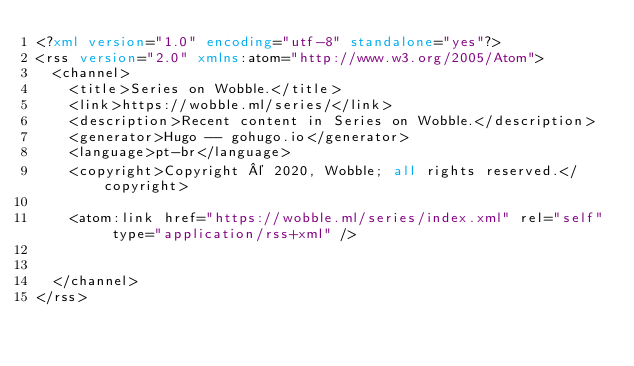Convert code to text. <code><loc_0><loc_0><loc_500><loc_500><_XML_><?xml version="1.0" encoding="utf-8" standalone="yes"?>
<rss version="2.0" xmlns:atom="http://www.w3.org/2005/Atom">
  <channel>
    <title>Series on Wobble.</title>
    <link>https://wobble.ml/series/</link>
    <description>Recent content in Series on Wobble.</description>
    <generator>Hugo -- gohugo.io</generator>
    <language>pt-br</language>
    <copyright>Copyright © 2020, Wobble; all rights reserved.</copyright>
    
	<atom:link href="https://wobble.ml/series/index.xml" rel="self" type="application/rss+xml" />
    
    
  </channel>
</rss></code> 